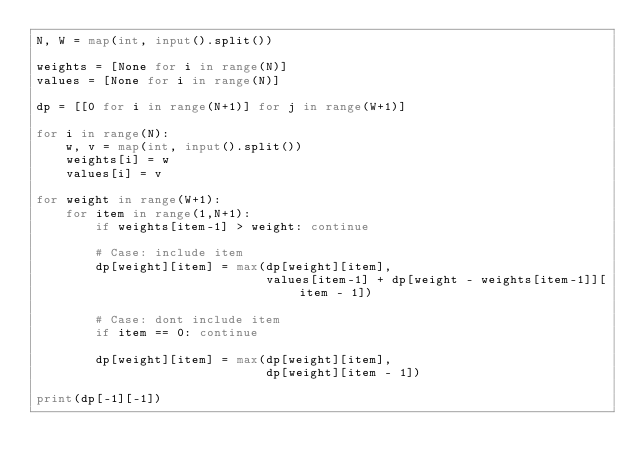<code> <loc_0><loc_0><loc_500><loc_500><_Python_>N, W = map(int, input().split())

weights = [None for i in range(N)]
values = [None for i in range(N)]

dp = [[0 for i in range(N+1)] for j in range(W+1)]

for i in range(N):
    w, v = map(int, input().split())
    weights[i] = w
    values[i] = v
    
for weight in range(W+1):
    for item in range(1,N+1):
        if weights[item-1] > weight: continue

        # Case: include item
        dp[weight][item] = max(dp[weight][item],
                               values[item-1] + dp[weight - weights[item-1]][item - 1])

        # Case: dont include item
        if item == 0: continue
        
        dp[weight][item] = max(dp[weight][item],
                               dp[weight][item - 1])

print(dp[-1][-1])
</code> 